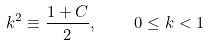Convert formula to latex. <formula><loc_0><loc_0><loc_500><loc_500>k ^ { 2 } \equiv \frac { 1 + C } { 2 } , \quad 0 \leq k < 1</formula> 